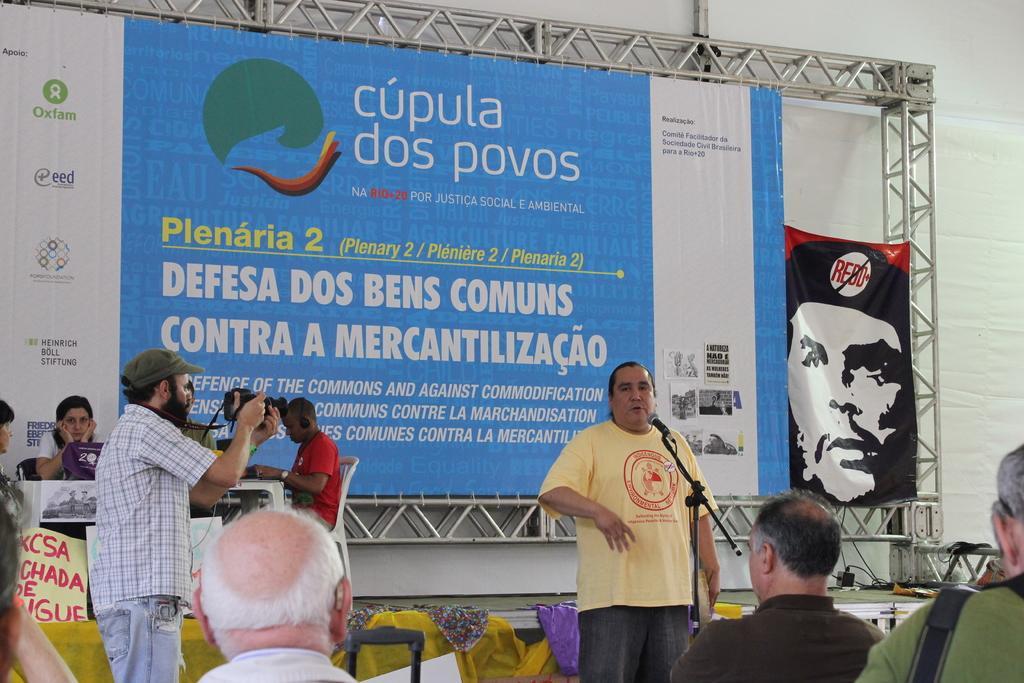In one or two sentences, can you explain what this image depicts? In this image we can see a person standing near a mic. To the left side of the image there is another person holding a camera. At the bottom of the image there are people. In the background of the image there are people sitting on chairs. There is a banner with some text. There are rods. 